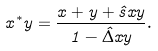Convert formula to latex. <formula><loc_0><loc_0><loc_500><loc_500>x ^ { * } y = \frac { x + y + \hat { s } x y } { 1 - \hat { \Delta } x y } .</formula> 